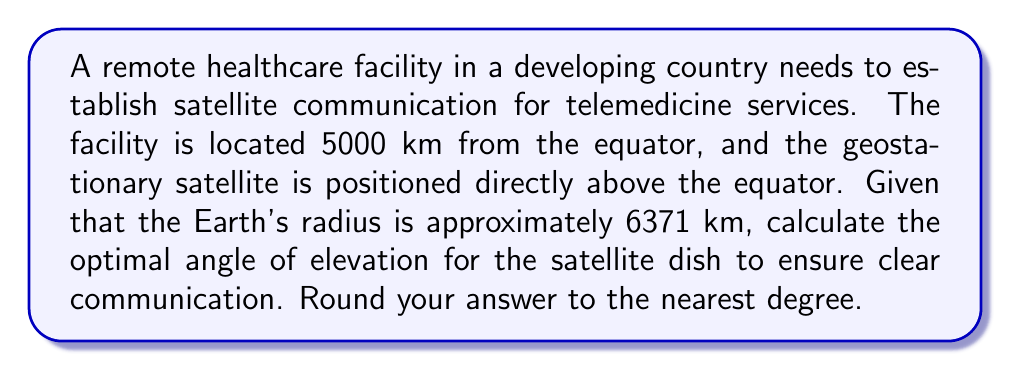Teach me how to tackle this problem. To solve this problem, we need to use trigonometry in the context of a right-angled triangle formed by the Earth's center, the healthcare facility, and the geostationary satellite.

Let's break it down step-by-step:

1) First, we need to calculate the distance from the Earth's center to the geostationary satellite. Geostationary satellites orbit at an altitude of approximately 35,786 km above the Earth's surface.

   Distance to satellite = Earth's radius + Satellite altitude
   $$ d = 6371 + 35786 = 42157 \text{ km} $$

2) Now we have a right-angled triangle with the following sides:
   - Adjacent side (a): radius of Earth = 6371 km
   - Opposite side (o): distance from facility to equator = 5000 km
   - Hypotenuse (h): distance to satellite = 42157 km

3) We need to find the angle of elevation, which is the angle between the horizontal plane at the facility and the line of sight to the satellite. This angle is complementary to the angle at the Earth's center.

4) Let's call the angle at the Earth's center θ. We can find this using the cosine function:

   $$ \cos(\theta) = \frac{\text{adjacent}}{\text{hypotenuse}} = \frac{6371}{42157} $$

5) Taking the arccos of both sides:

   $$ \theta = \arccos(\frac{6371}{42157}) \approx 1.3947 \text{ radians} $$

6) Convert to degrees:

   $$ \theta \approx 1.3947 \times \frac{180}{\pi} \approx 79.92° $$

7) The angle of elevation is the complement of this angle:

   Angle of elevation = 90° - 79.92° ≈ 10.08°

8) Rounding to the nearest degree:

   Angle of elevation ≈ 10°

[asy]
import geometry;

size(200);

pair O = (0,0);
pair E = (63.71,0);
pair F = (63.71,50);
pair S = (421.57,0);

draw(O--E--F--cycle,black);
draw(F--S,black);

label("Earth's center", O, SW);
label("Equator", E, S);
label("Facility", F, NE);
label("Satellite", S, SE);

draw(arc(F,5,0,10.08),blue);
label("10°", F+(4,2), NE, blue);

draw(arc(O,10,79.92,90),red);
label("79.92°", O+(8,8), NE, red);
[/asy]
Answer: 10° 